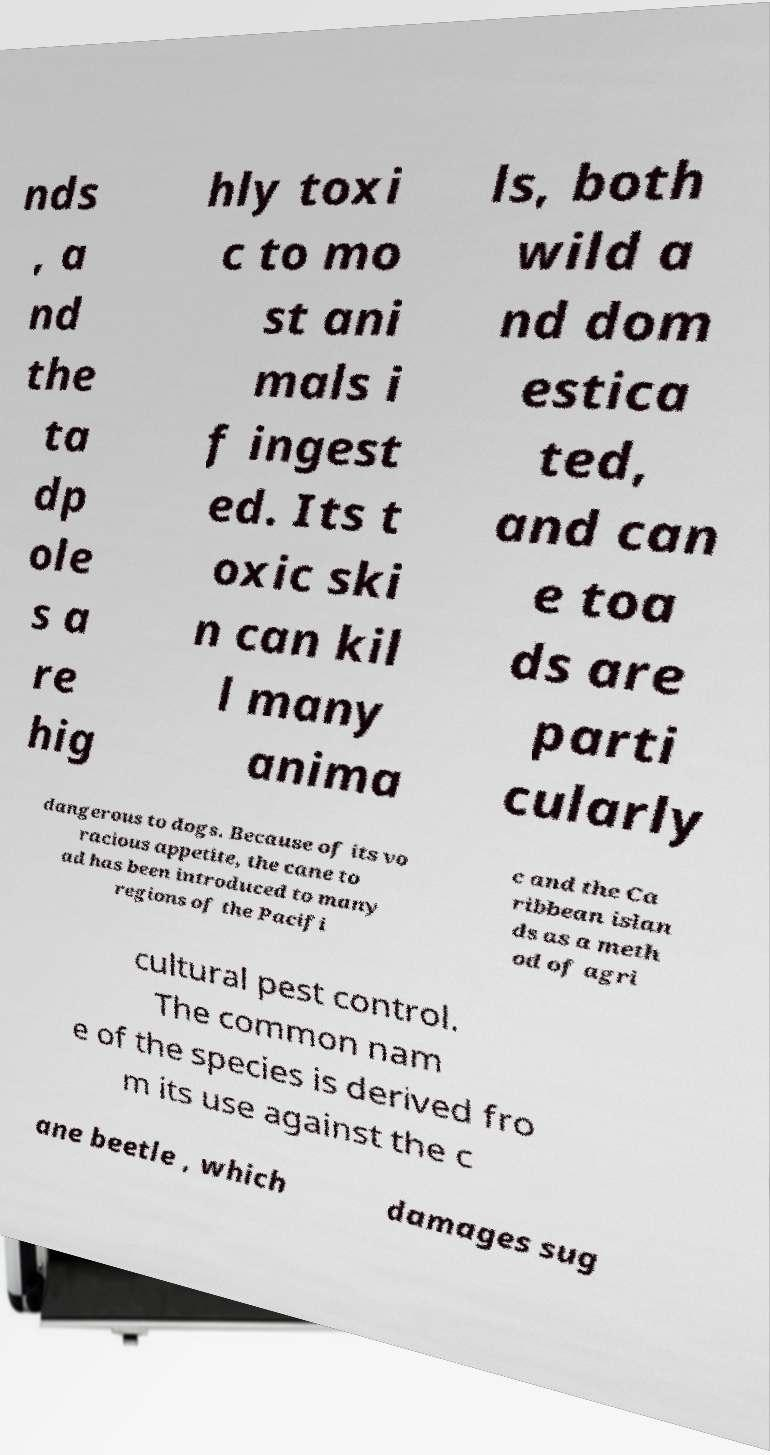Please read and relay the text visible in this image. What does it say? nds , a nd the ta dp ole s a re hig hly toxi c to mo st ani mals i f ingest ed. Its t oxic ski n can kil l many anima ls, both wild a nd dom estica ted, and can e toa ds are parti cularly dangerous to dogs. Because of its vo racious appetite, the cane to ad has been introduced to many regions of the Pacifi c and the Ca ribbean islan ds as a meth od of agri cultural pest control. The common nam e of the species is derived fro m its use against the c ane beetle , which damages sug 